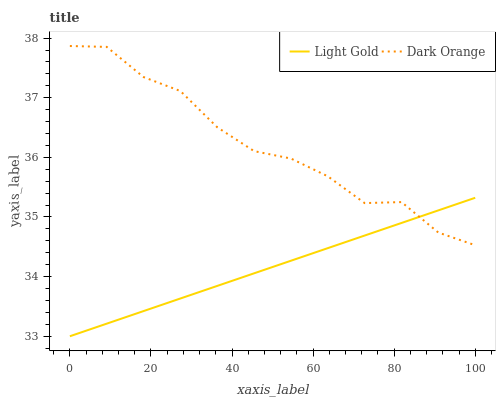Does Light Gold have the minimum area under the curve?
Answer yes or no. Yes. Does Dark Orange have the maximum area under the curve?
Answer yes or no. Yes. Does Light Gold have the maximum area under the curve?
Answer yes or no. No. Is Light Gold the smoothest?
Answer yes or no. Yes. Is Dark Orange the roughest?
Answer yes or no. Yes. Is Light Gold the roughest?
Answer yes or no. No. Does Light Gold have the lowest value?
Answer yes or no. Yes. Does Dark Orange have the highest value?
Answer yes or no. Yes. Does Light Gold have the highest value?
Answer yes or no. No. Does Dark Orange intersect Light Gold?
Answer yes or no. Yes. Is Dark Orange less than Light Gold?
Answer yes or no. No. Is Dark Orange greater than Light Gold?
Answer yes or no. No. 